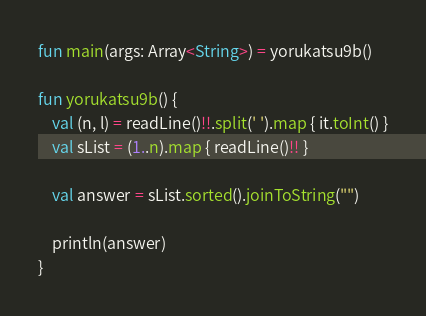<code> <loc_0><loc_0><loc_500><loc_500><_Kotlin_>fun main(args: Array<String>) = yorukatsu9b()

fun yorukatsu9b() {
    val (n, l) = readLine()!!.split(' ').map { it.toInt() }
    val sList = (1..n).map { readLine()!! }

    val answer = sList.sorted().joinToString("")

    println(answer)
}
</code> 